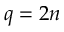<formula> <loc_0><loc_0><loc_500><loc_500>q = 2 n</formula> 